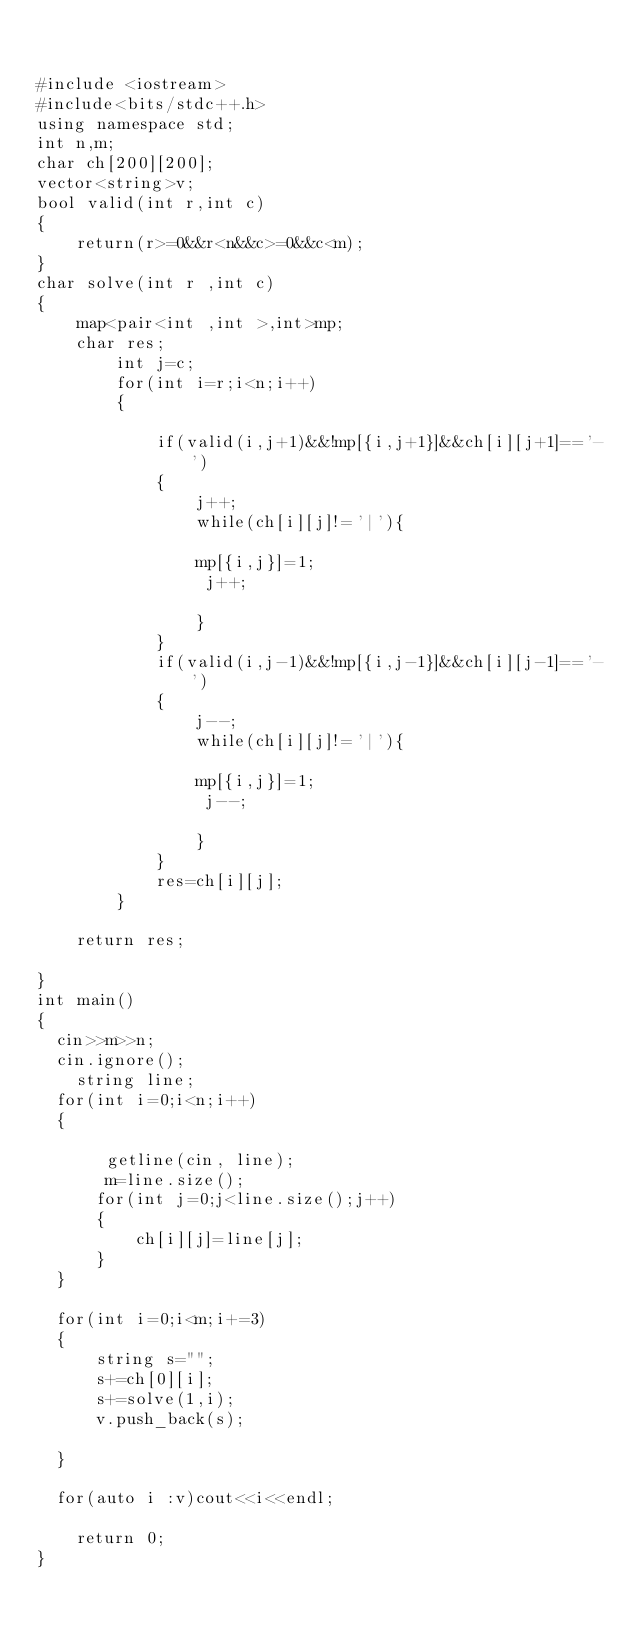<code> <loc_0><loc_0><loc_500><loc_500><_C++_>

#include <iostream>
#include<bits/stdc++.h>
using namespace std;
int n,m;
char ch[200][200];
vector<string>v;
bool valid(int r,int c)
{
    return(r>=0&&r<n&&c>=0&&c<m);
}
char solve(int r ,int c)
{
    map<pair<int ,int >,int>mp;
    char res;
        int j=c;
        for(int i=r;i<n;i++)
        {
           
            if(valid(i,j+1)&&!mp[{i,j+1}]&&ch[i][j+1]=='-')
            {
                j++;
                while(ch[i][j]!='|'){
              
                mp[{i,j}]=1;
                 j++;
                
                }
            }
            if(valid(i,j-1)&&!mp[{i,j-1}]&&ch[i][j-1]=='-')
            {
                j--;
                while(ch[i][j]!='|'){
              
                mp[{i,j}]=1;
                 j--;
                
                }
            }
            res=ch[i][j];
        }
   
    return res;
    
}
int main()
{
  cin>>m>>n;
  cin.ignore();
    string line;
  for(int i=0;i<n;i++)
  {
    
       getline(cin, line);
       m=line.size();
      for(int j=0;j<line.size();j++)
      {
          ch[i][j]=line[j];
      }
  }

  for(int i=0;i<m;i+=3)
  {
      string s="";
      s+=ch[0][i];
      s+=solve(1,i);
      v.push_back(s);
    
  }
  
  for(auto i :v)cout<<i<<endl;
 
    return 0;
}
</code> 